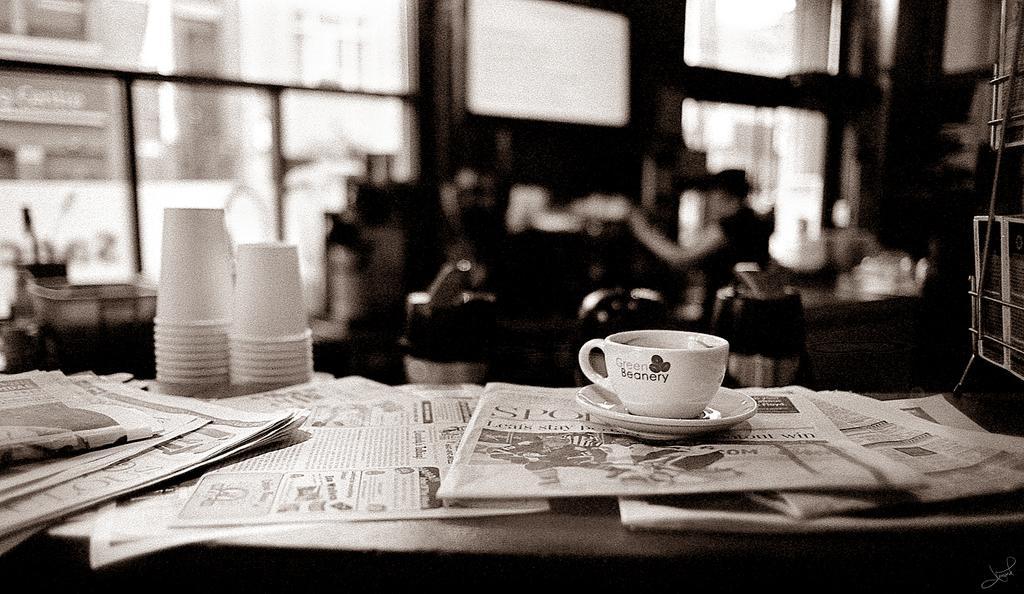In one or two sentences, can you explain what this image depicts? This Picture describe a vintage photograph in which a tea cup and saucer on which green beanery is written. Beside a disposable tea paper cup are kept and behind we can see the a man with cow boy cap is sitting on the chair and a big glass window from which building and road is seen. 